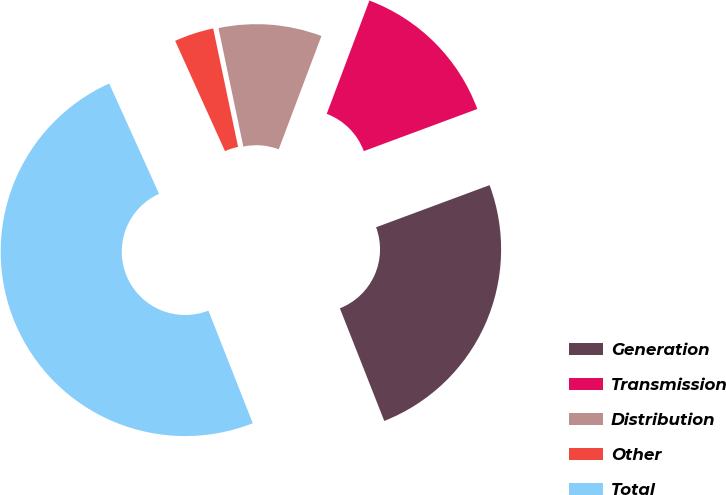<chart> <loc_0><loc_0><loc_500><loc_500><pie_chart><fcel>Generation<fcel>Transmission<fcel>Distribution<fcel>Other<fcel>Total<nl><fcel>24.68%<fcel>13.61%<fcel>9.03%<fcel>3.46%<fcel>49.22%<nl></chart> 